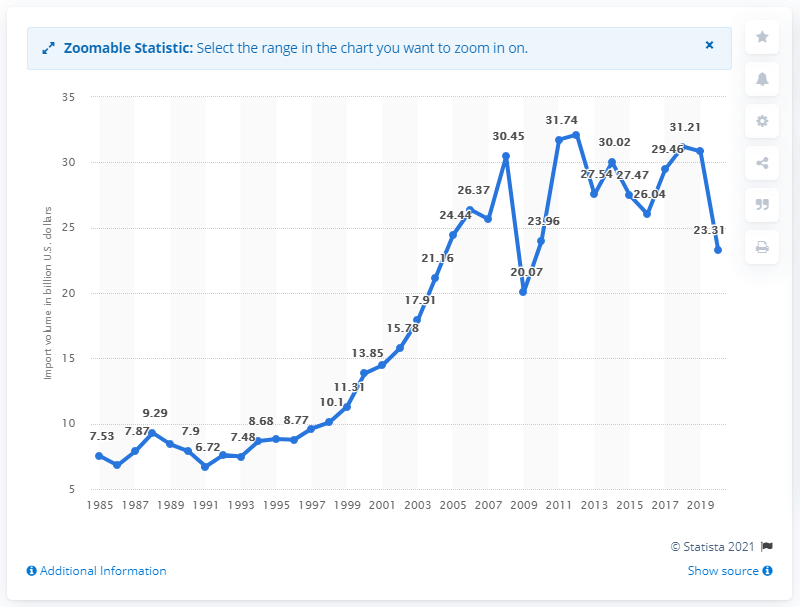How has the trend of U.S. imports from Brazil changed over the last decade according to the chart? Over the last decade, the chart demonstrates a fluctuating trend in the value of U.S. imports from Brazil. Starting with an upswing that peaks in 2011 at around $30.45 billion, there's a subsequent dip and recovery, with notable oscillations peaking in 2017 and 2018, before declining again in 2020. 